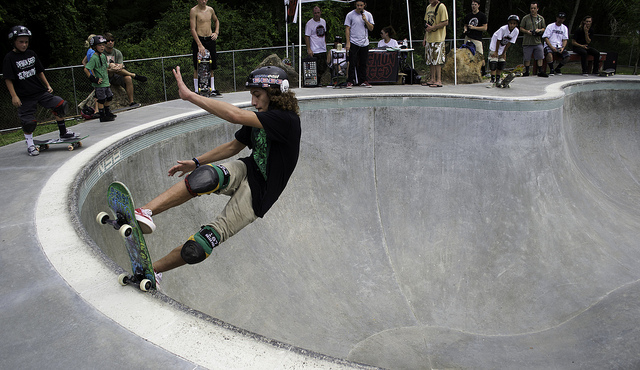Describe the setting where the skateboarder is performing. The skateboarder is performing in a well-designed concrete skate bowl, with spectators watching from the edges, suggesting a community skate park atmosphere. 